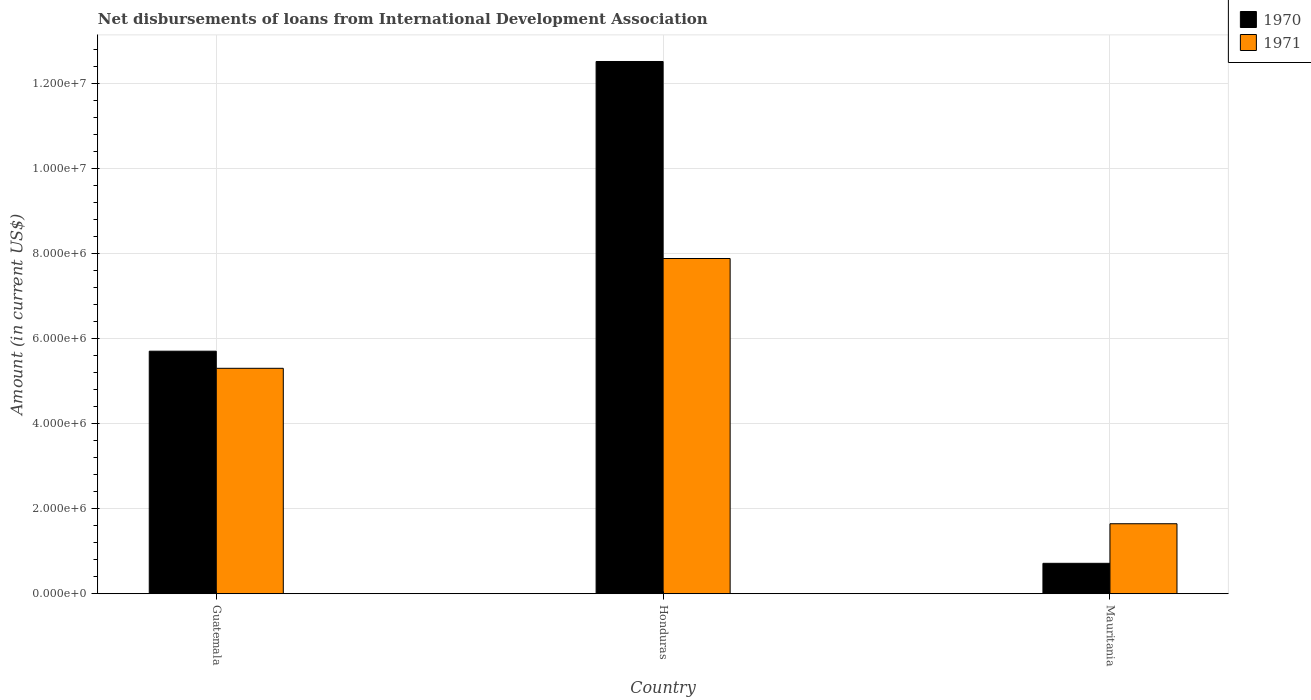How many different coloured bars are there?
Your response must be concise. 2. Are the number of bars on each tick of the X-axis equal?
Offer a terse response. Yes. How many bars are there on the 1st tick from the left?
Keep it short and to the point. 2. What is the label of the 1st group of bars from the left?
Your answer should be compact. Guatemala. In how many cases, is the number of bars for a given country not equal to the number of legend labels?
Your answer should be very brief. 0. What is the amount of loans disbursed in 1971 in Guatemala?
Give a very brief answer. 5.30e+06. Across all countries, what is the maximum amount of loans disbursed in 1970?
Ensure brevity in your answer.  1.25e+07. Across all countries, what is the minimum amount of loans disbursed in 1971?
Provide a succinct answer. 1.64e+06. In which country was the amount of loans disbursed in 1971 maximum?
Offer a terse response. Honduras. In which country was the amount of loans disbursed in 1971 minimum?
Provide a succinct answer. Mauritania. What is the total amount of loans disbursed in 1970 in the graph?
Make the answer very short. 1.89e+07. What is the difference between the amount of loans disbursed in 1971 in Guatemala and that in Honduras?
Make the answer very short. -2.58e+06. What is the difference between the amount of loans disbursed in 1970 in Guatemala and the amount of loans disbursed in 1971 in Honduras?
Offer a very short reply. -2.18e+06. What is the average amount of loans disbursed in 1971 per country?
Make the answer very short. 4.94e+06. What is the difference between the amount of loans disbursed of/in 1970 and amount of loans disbursed of/in 1971 in Honduras?
Make the answer very short. 4.63e+06. In how many countries, is the amount of loans disbursed in 1970 greater than 8800000 US$?
Your response must be concise. 1. What is the ratio of the amount of loans disbursed in 1970 in Guatemala to that in Honduras?
Give a very brief answer. 0.46. Is the amount of loans disbursed in 1970 in Honduras less than that in Mauritania?
Offer a terse response. No. What is the difference between the highest and the second highest amount of loans disbursed in 1971?
Give a very brief answer. 2.58e+06. What is the difference between the highest and the lowest amount of loans disbursed in 1971?
Offer a terse response. 6.23e+06. In how many countries, is the amount of loans disbursed in 1970 greater than the average amount of loans disbursed in 1970 taken over all countries?
Provide a succinct answer. 1. What does the 2nd bar from the right in Mauritania represents?
Offer a terse response. 1970. How many bars are there?
Give a very brief answer. 6. Are all the bars in the graph horizontal?
Provide a short and direct response. No. How many countries are there in the graph?
Provide a succinct answer. 3. Does the graph contain any zero values?
Your answer should be compact. No. Where does the legend appear in the graph?
Make the answer very short. Top right. How many legend labels are there?
Give a very brief answer. 2. What is the title of the graph?
Keep it short and to the point. Net disbursements of loans from International Development Association. What is the Amount (in current US$) in 1970 in Guatemala?
Your answer should be compact. 5.70e+06. What is the Amount (in current US$) of 1971 in Guatemala?
Make the answer very short. 5.30e+06. What is the Amount (in current US$) of 1970 in Honduras?
Ensure brevity in your answer.  1.25e+07. What is the Amount (in current US$) of 1971 in Honduras?
Offer a very short reply. 7.88e+06. What is the Amount (in current US$) in 1970 in Mauritania?
Your response must be concise. 7.15e+05. What is the Amount (in current US$) of 1971 in Mauritania?
Your answer should be compact. 1.64e+06. Across all countries, what is the maximum Amount (in current US$) in 1970?
Provide a short and direct response. 1.25e+07. Across all countries, what is the maximum Amount (in current US$) in 1971?
Your response must be concise. 7.88e+06. Across all countries, what is the minimum Amount (in current US$) in 1970?
Ensure brevity in your answer.  7.15e+05. Across all countries, what is the minimum Amount (in current US$) of 1971?
Provide a short and direct response. 1.64e+06. What is the total Amount (in current US$) in 1970 in the graph?
Give a very brief answer. 1.89e+07. What is the total Amount (in current US$) of 1971 in the graph?
Provide a short and direct response. 1.48e+07. What is the difference between the Amount (in current US$) in 1970 in Guatemala and that in Honduras?
Give a very brief answer. -6.81e+06. What is the difference between the Amount (in current US$) of 1971 in Guatemala and that in Honduras?
Provide a short and direct response. -2.58e+06. What is the difference between the Amount (in current US$) in 1970 in Guatemala and that in Mauritania?
Provide a short and direct response. 4.98e+06. What is the difference between the Amount (in current US$) in 1971 in Guatemala and that in Mauritania?
Your response must be concise. 3.65e+06. What is the difference between the Amount (in current US$) of 1970 in Honduras and that in Mauritania?
Provide a succinct answer. 1.18e+07. What is the difference between the Amount (in current US$) of 1971 in Honduras and that in Mauritania?
Make the answer very short. 6.23e+06. What is the difference between the Amount (in current US$) of 1970 in Guatemala and the Amount (in current US$) of 1971 in Honduras?
Keep it short and to the point. -2.18e+06. What is the difference between the Amount (in current US$) in 1970 in Guatemala and the Amount (in current US$) in 1971 in Mauritania?
Offer a terse response. 4.06e+06. What is the difference between the Amount (in current US$) in 1970 in Honduras and the Amount (in current US$) in 1971 in Mauritania?
Your response must be concise. 1.09e+07. What is the average Amount (in current US$) in 1970 per country?
Provide a succinct answer. 6.31e+06. What is the average Amount (in current US$) in 1971 per country?
Make the answer very short. 4.94e+06. What is the difference between the Amount (in current US$) in 1970 and Amount (in current US$) in 1971 in Guatemala?
Offer a terse response. 4.02e+05. What is the difference between the Amount (in current US$) of 1970 and Amount (in current US$) of 1971 in Honduras?
Give a very brief answer. 4.63e+06. What is the difference between the Amount (in current US$) of 1970 and Amount (in current US$) of 1971 in Mauritania?
Give a very brief answer. -9.30e+05. What is the ratio of the Amount (in current US$) of 1970 in Guatemala to that in Honduras?
Your answer should be compact. 0.46. What is the ratio of the Amount (in current US$) in 1971 in Guatemala to that in Honduras?
Provide a succinct answer. 0.67. What is the ratio of the Amount (in current US$) of 1970 in Guatemala to that in Mauritania?
Provide a short and direct response. 7.97. What is the ratio of the Amount (in current US$) of 1971 in Guatemala to that in Mauritania?
Provide a succinct answer. 3.22. What is the ratio of the Amount (in current US$) of 1970 in Honduras to that in Mauritania?
Provide a succinct answer. 17.49. What is the ratio of the Amount (in current US$) in 1971 in Honduras to that in Mauritania?
Your answer should be compact. 4.79. What is the difference between the highest and the second highest Amount (in current US$) in 1970?
Provide a short and direct response. 6.81e+06. What is the difference between the highest and the second highest Amount (in current US$) of 1971?
Offer a very short reply. 2.58e+06. What is the difference between the highest and the lowest Amount (in current US$) in 1970?
Give a very brief answer. 1.18e+07. What is the difference between the highest and the lowest Amount (in current US$) of 1971?
Your answer should be very brief. 6.23e+06. 